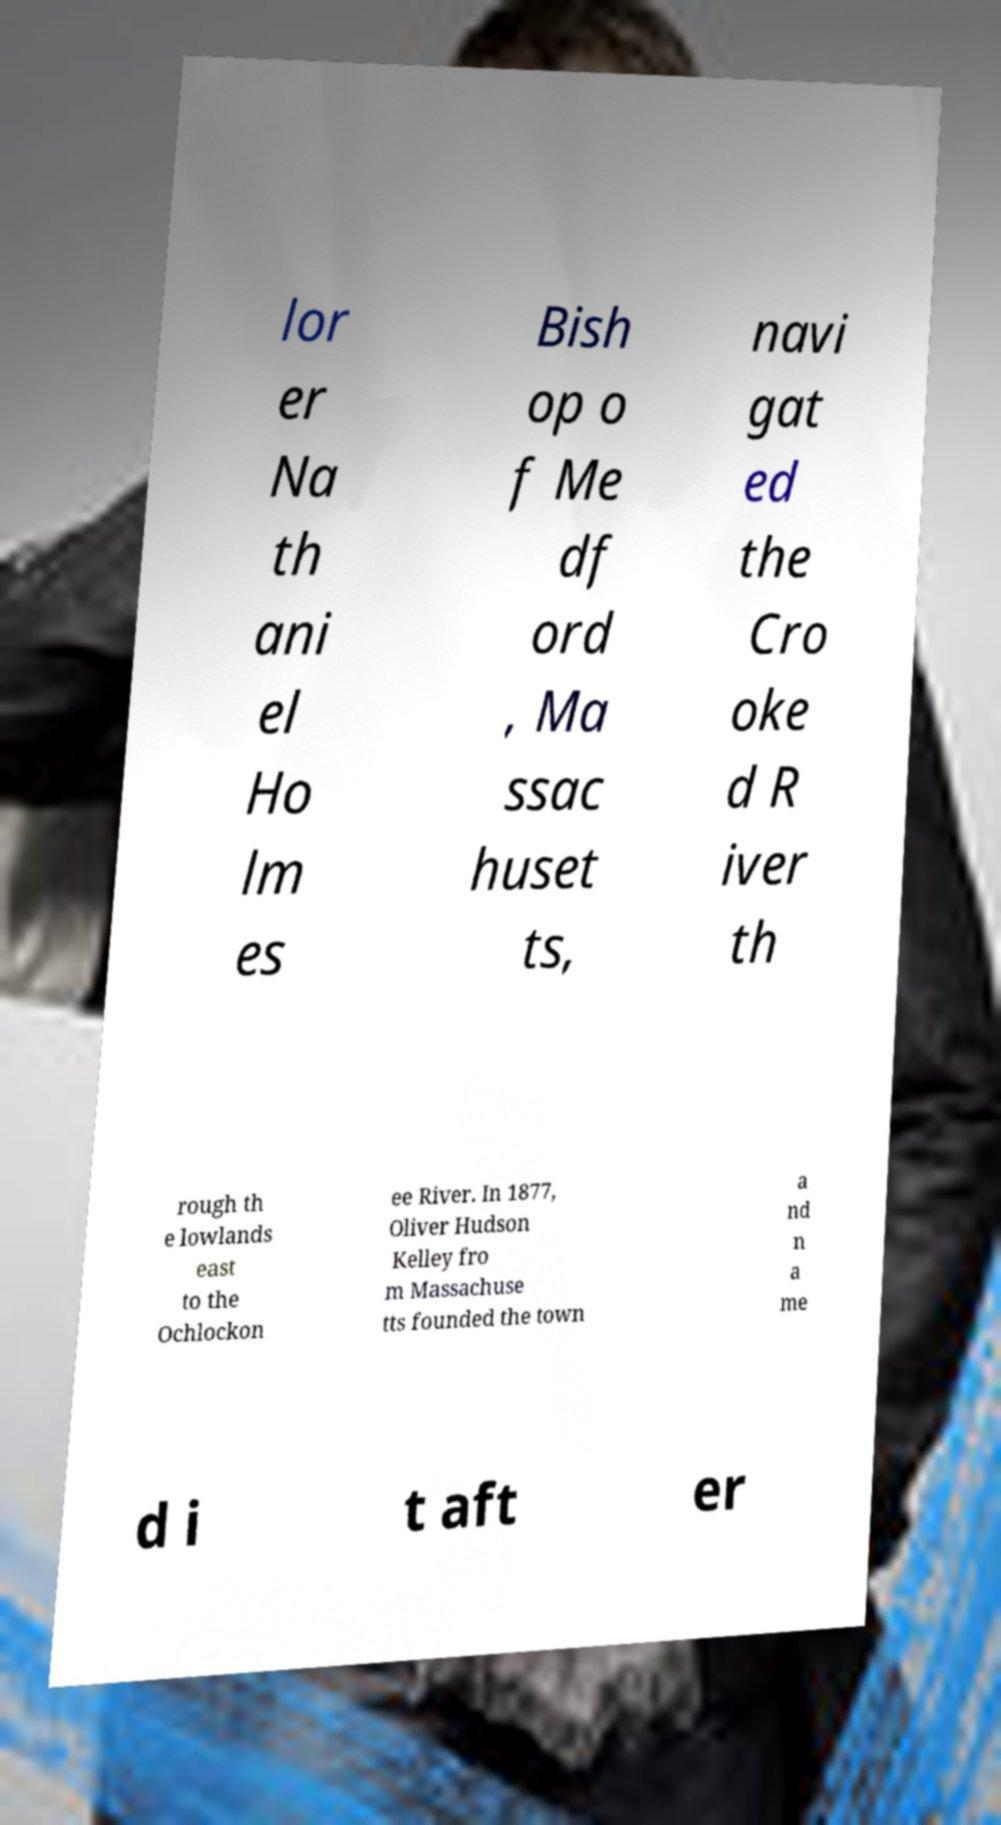Could you assist in decoding the text presented in this image and type it out clearly? lor er Na th ani el Ho lm es Bish op o f Me df ord , Ma ssac huset ts, navi gat ed the Cro oke d R iver th rough th e lowlands east to the Ochlockon ee River. In 1877, Oliver Hudson Kelley fro m Massachuse tts founded the town a nd n a me d i t aft er 